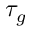Convert formula to latex. <formula><loc_0><loc_0><loc_500><loc_500>\tau _ { g }</formula> 